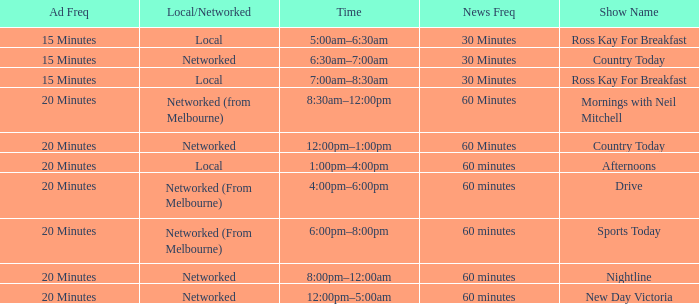What Time has a Show Name of mornings with neil mitchell? 8:30am–12:00pm. 